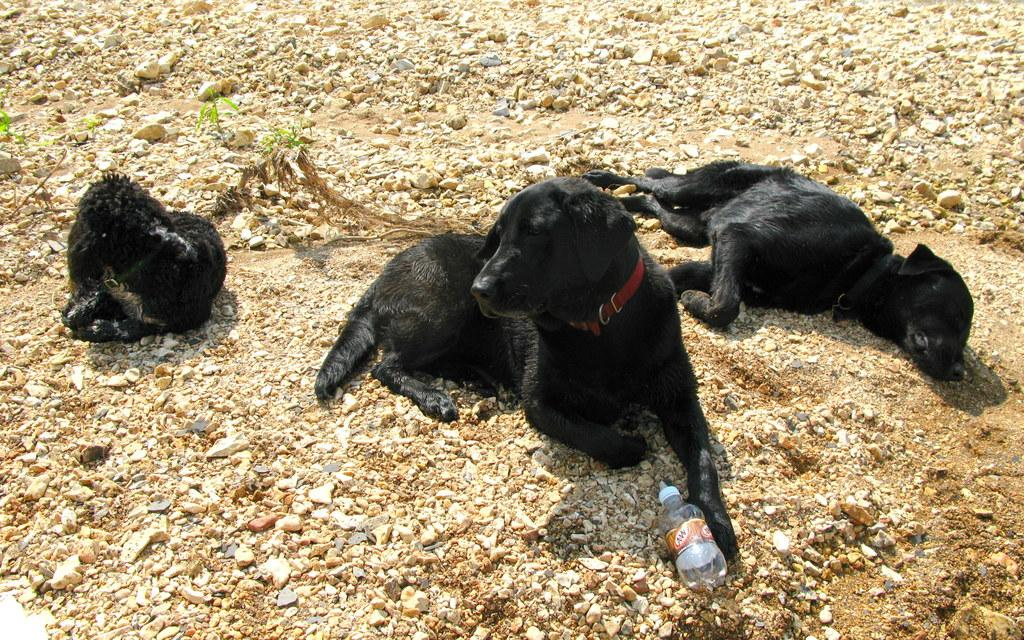What color are the dogs in the image? The dogs in the image are black colored. Where are the dogs located in the image? The dogs are on the ground. What type of surface can be seen in the image? There is grass visible in the image. What other objects can be seen in the image? There are stones and a bottle in the image. How much profit did the dogs make in the image? There is no mention of profit or any financial aspect in the image, as it features dogs on the ground with grass, stones, and a bottle. 